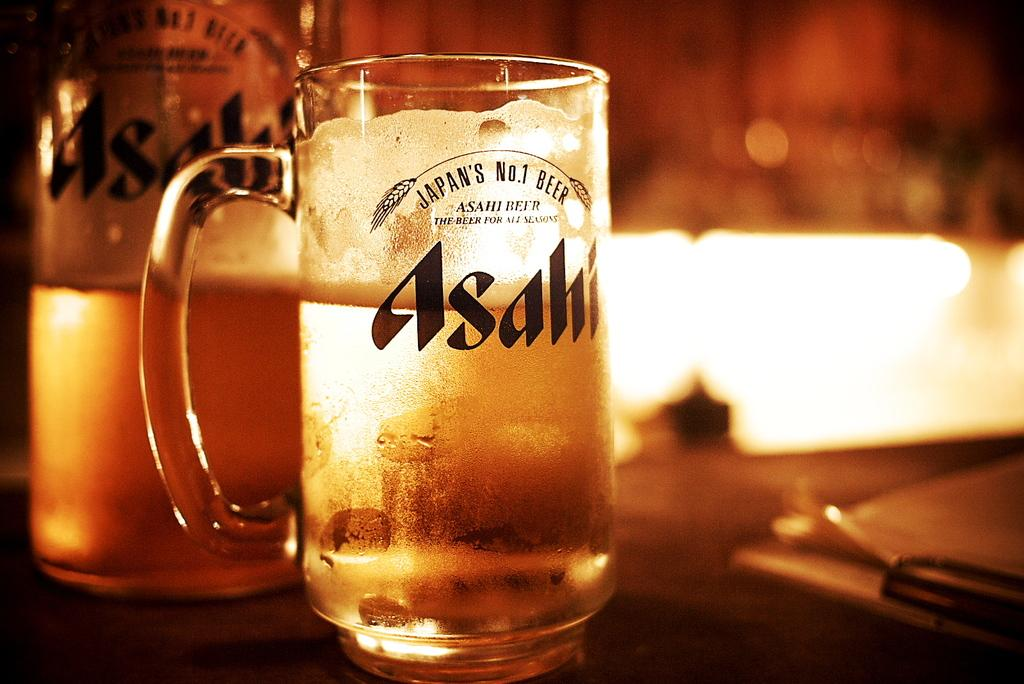What is in the glass that is visible in the image? There is a beer glass in the image. Where is the beer glass located? The beer glass is on a table. What other beer-related item can be seen in the image? There is a beer bottle in the image. How is the beer bottle positioned in relation to the beer glass? The beer bottle is beside the beer glass. What type of haircut does the beer bottle have in the image? There is no haircut present in the image, as the beer bottle is an inanimate object. 